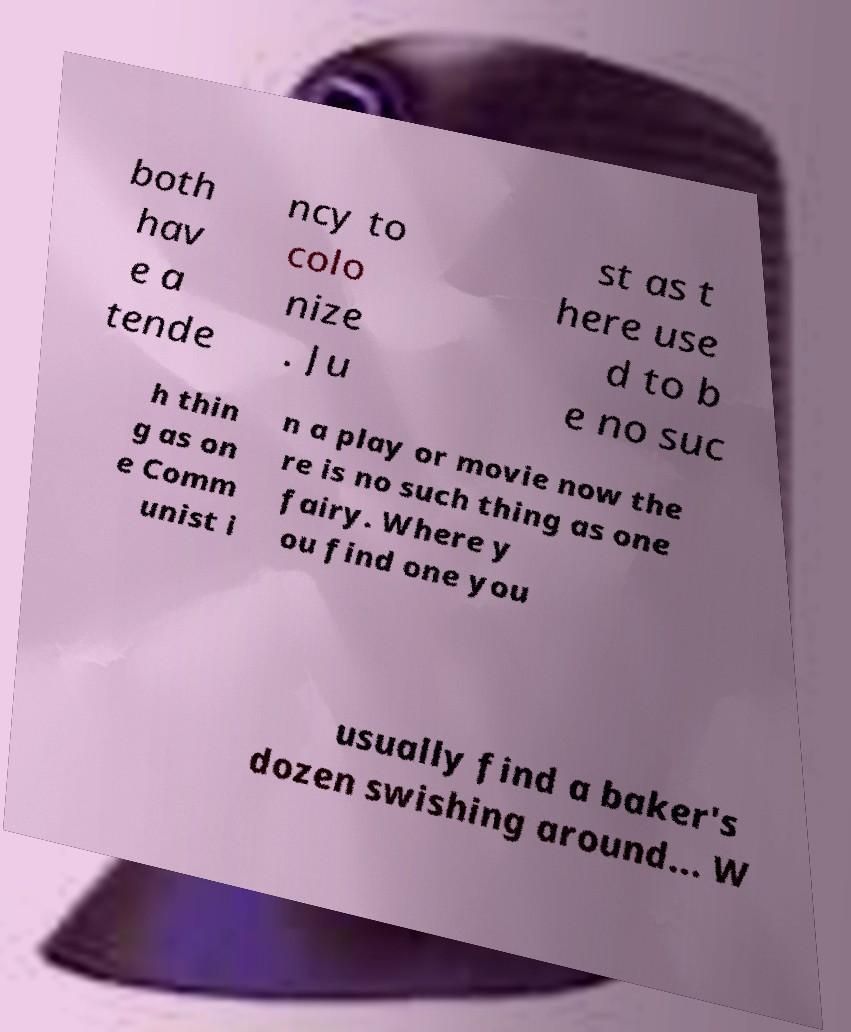For documentation purposes, I need the text within this image transcribed. Could you provide that? both hav e a tende ncy to colo nize . Ju st as t here use d to b e no suc h thin g as on e Comm unist i n a play or movie now the re is no such thing as one fairy. Where y ou find one you usually find a baker's dozen swishing around... W 